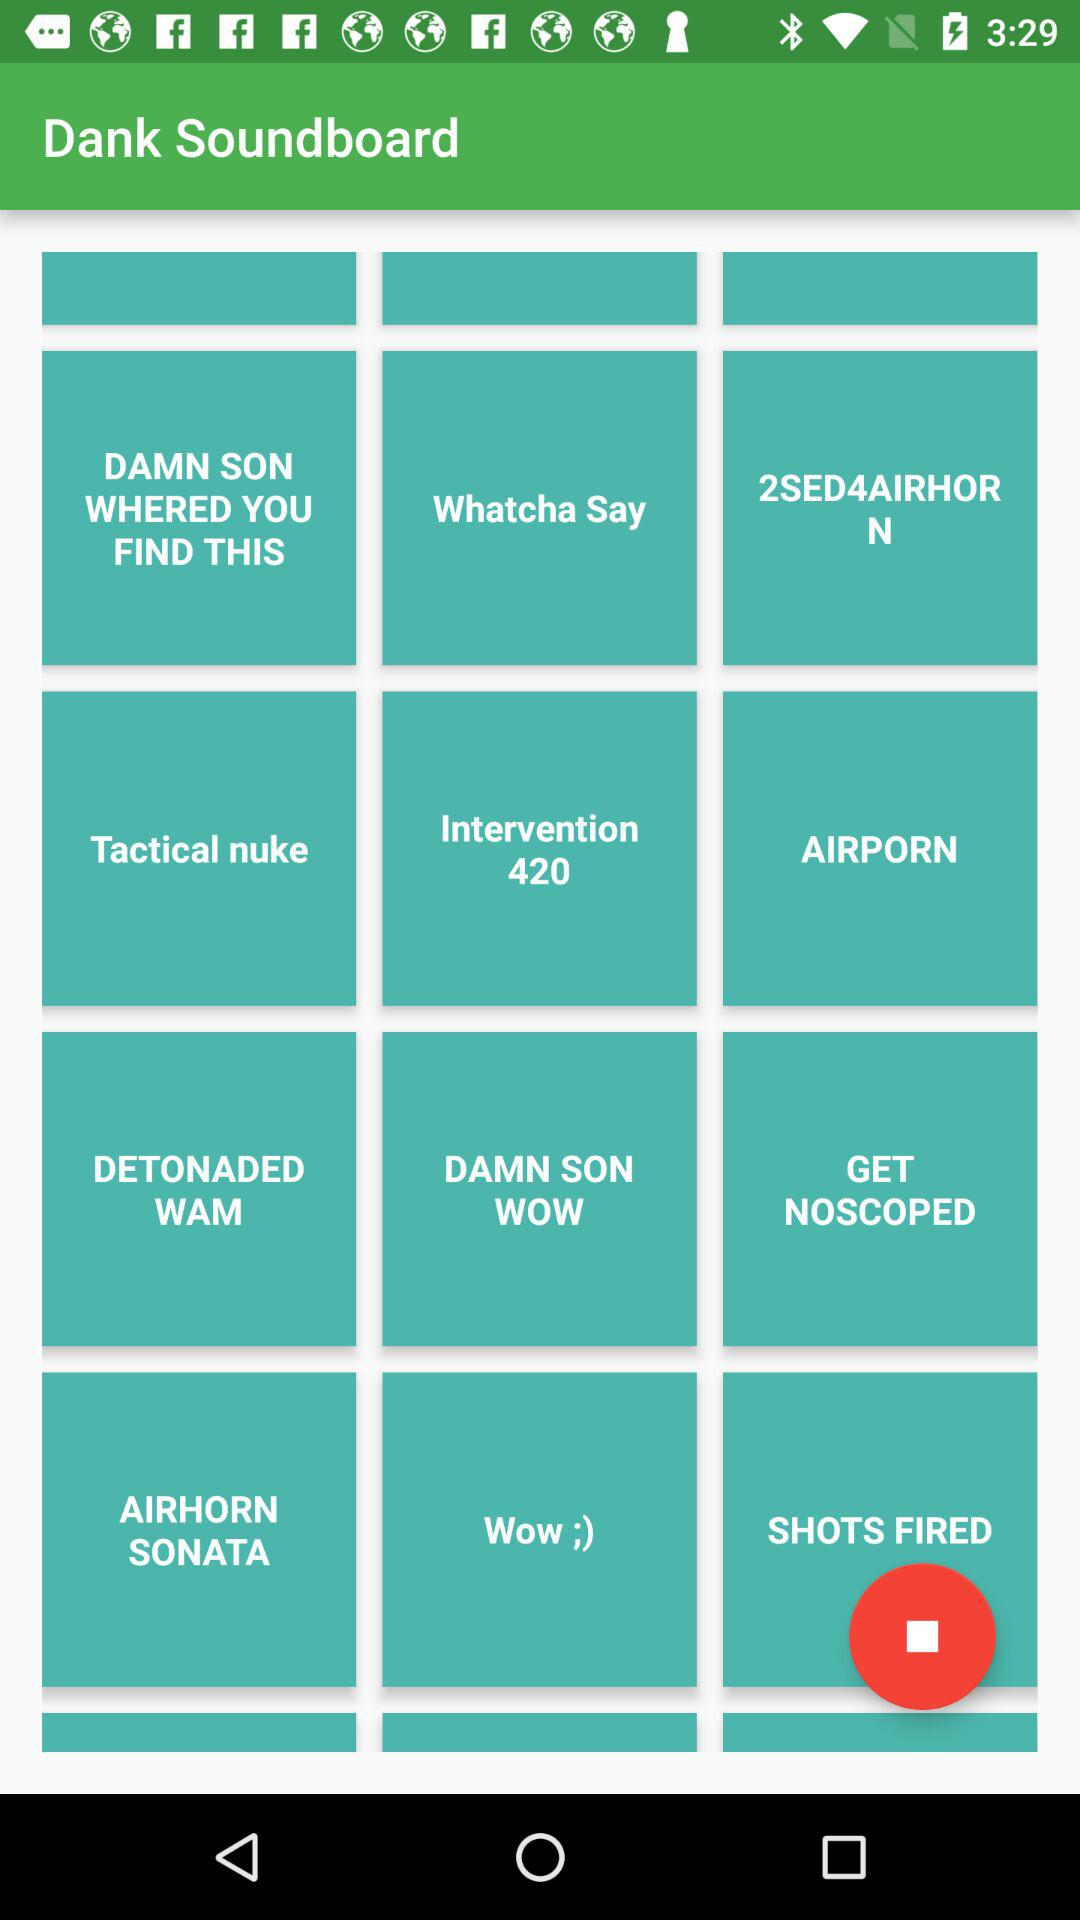What is the application name? The application name is "Dank Soundboard". 